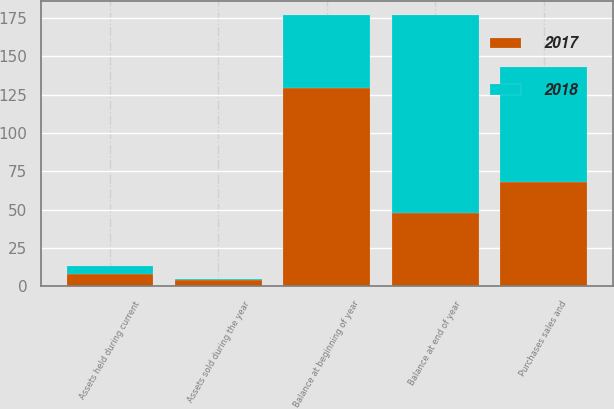<chart> <loc_0><loc_0><loc_500><loc_500><stacked_bar_chart><ecel><fcel>Balance at beginning of year<fcel>Assets held during current<fcel>Assets sold during the year<fcel>Purchases sales and<fcel>Balance at end of year<nl><fcel>2017<fcel>129<fcel>8<fcel>4<fcel>68<fcel>48<nl><fcel>2018<fcel>48<fcel>5<fcel>1<fcel>75<fcel>129<nl></chart> 